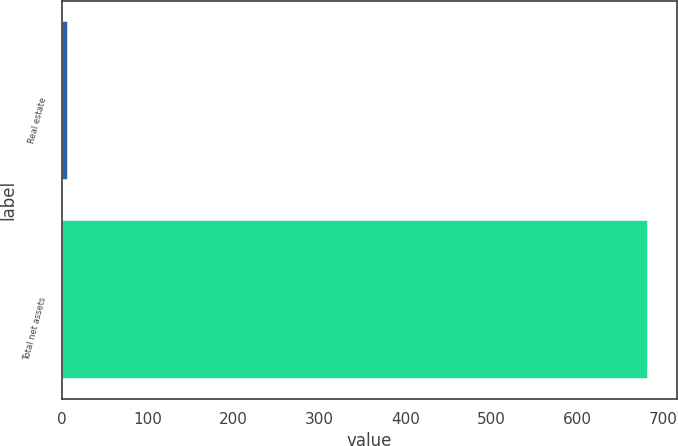Convert chart to OTSL. <chart><loc_0><loc_0><loc_500><loc_500><bar_chart><fcel>Real estate<fcel>Total net assets<nl><fcel>7<fcel>682<nl></chart> 